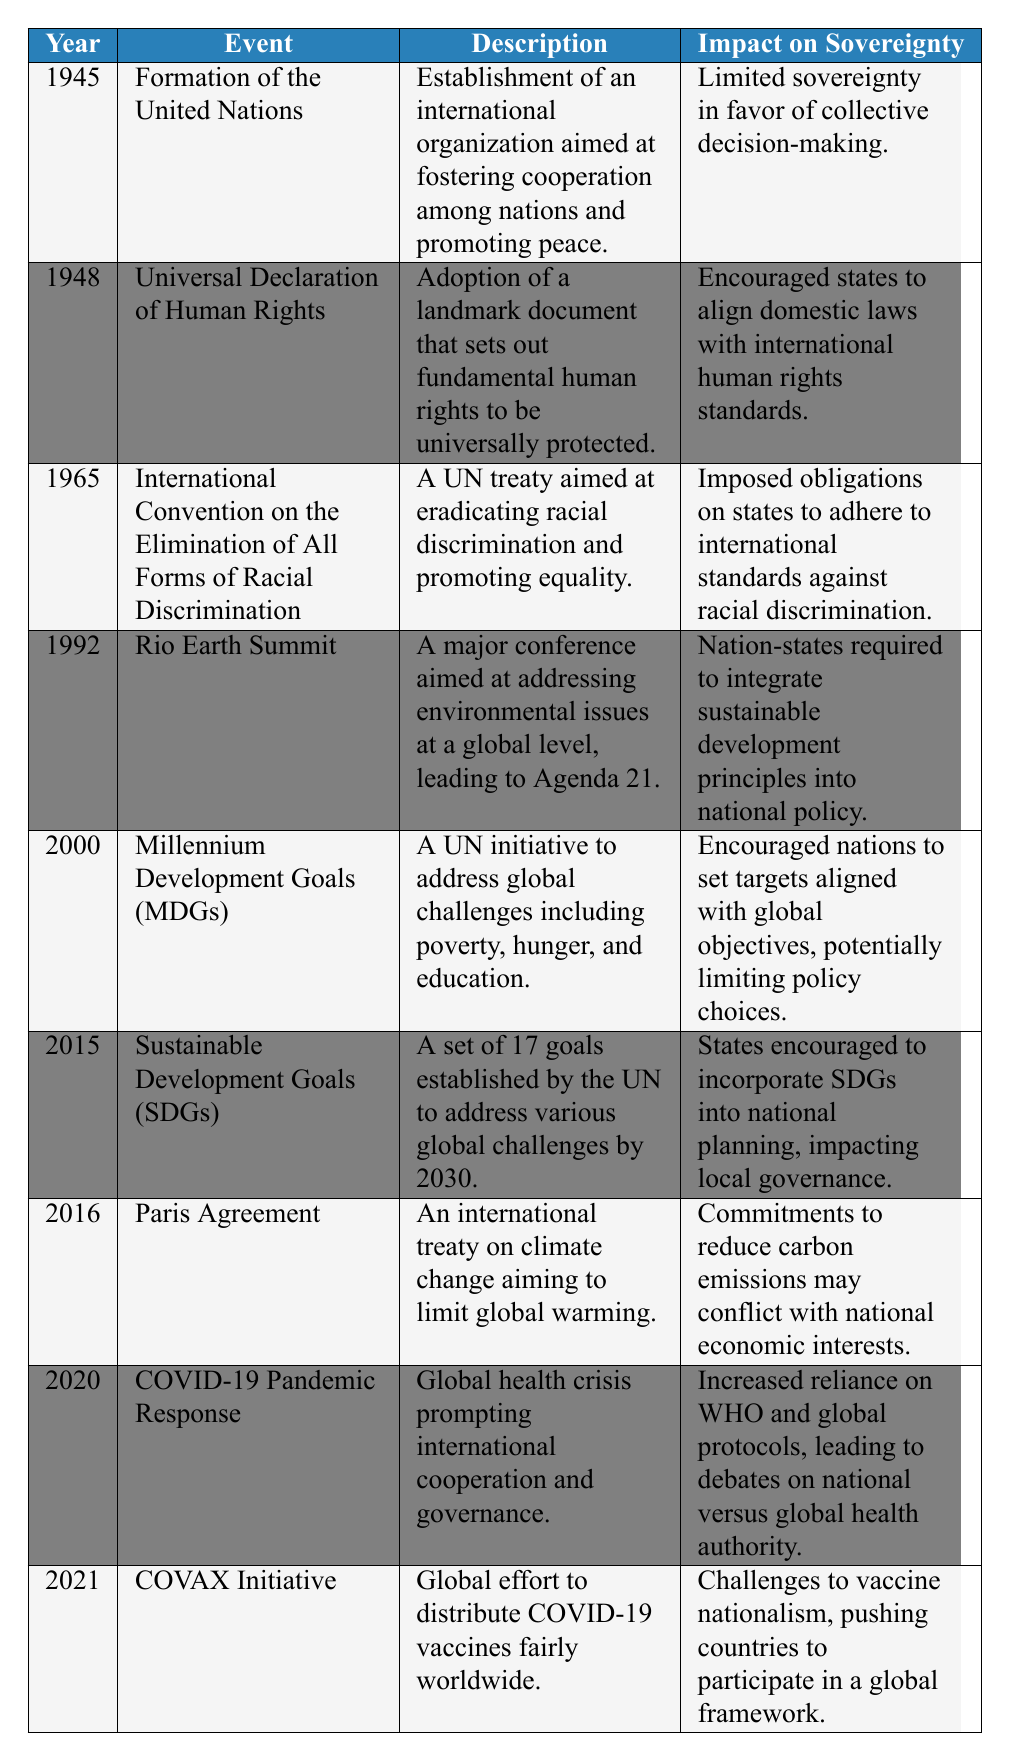What year was the United Nations formed? The table lists the formation of the United Nations under the year 1945.
Answer: 1945 What event in 2015 aims to address global challenges by 2030? The table indicates that the Sustainable Development Goals (SDGs) were established in 2015 to address various global challenges by 2030.
Answer: Sustainable Development Goals (SDGs) Which event imposed obligations on states to adhere to international standards against racial discrimination? According to the table, the International Convention on the Elimination of All Forms of Racial Discrimination in 1965 imposed these obligations.
Answer: International Convention on the Elimination of All Forms of Racial Discrimination Did the Rio Earth Summit of 1992 promote national sovereignty? The table states that the Rio Earth Summit required nation-states to integrate sustainable development principles into national policy, which can be interpreted as limiting sovereignty.
Answer: No In which year did the COVID-19 Pandemic Response prompt increased reliance on global health protocols? The table notes that the COVID-19 Pandemic Response occurred in 2020 and stated it led to increased reliance on WHO and global protocols.
Answer: 2020 How many events listed have a description related to international cooperation? By examining the table, we see that the Formation of the United Nations, COVID-19 Pandemic Response, and COVAX Initiative are all described in relation to international cooperation. That's three events.
Answer: 3 What is the overall trend in the impacts on sovereignty from the events listed in the table? Analyzing the impacts on sovereignty across the events, we can observe a trend where most events appear to limit national sovereignty in favor of global governance. This includes agreements and initiatives that require states to adhere to international norms and frameworks.
Answer: Most events limit sovereignty What event's impact on sovereignty may conflict with national economic interests? The table indicates that the Paris Agreement, established in 2016, discusses commitments to reduce carbon emissions that may conflict with national economic interests.
Answer: Paris Agreement What is the difference in years between the formation of the United Nations and the adoption of the Sustainable Development Goals? The formation of the United Nations was in 1945, while the Sustainable Development Goals were established in 2015. The difference is 2015 - 1945 = 70 years.
Answer: 70 years 